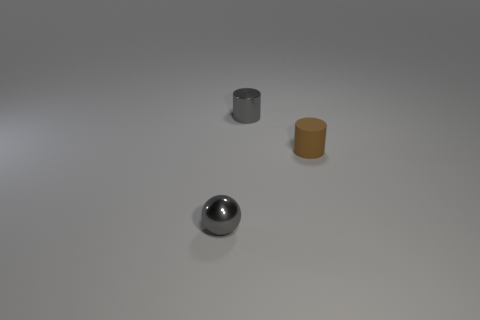Add 1 tiny gray balls. How many objects exist? 4 Subtract all spheres. How many objects are left? 2 Subtract all purple metallic cubes. Subtract all brown rubber objects. How many objects are left? 2 Add 3 brown matte objects. How many brown matte objects are left? 4 Add 2 metallic objects. How many metallic objects exist? 4 Subtract 0 red cubes. How many objects are left? 3 